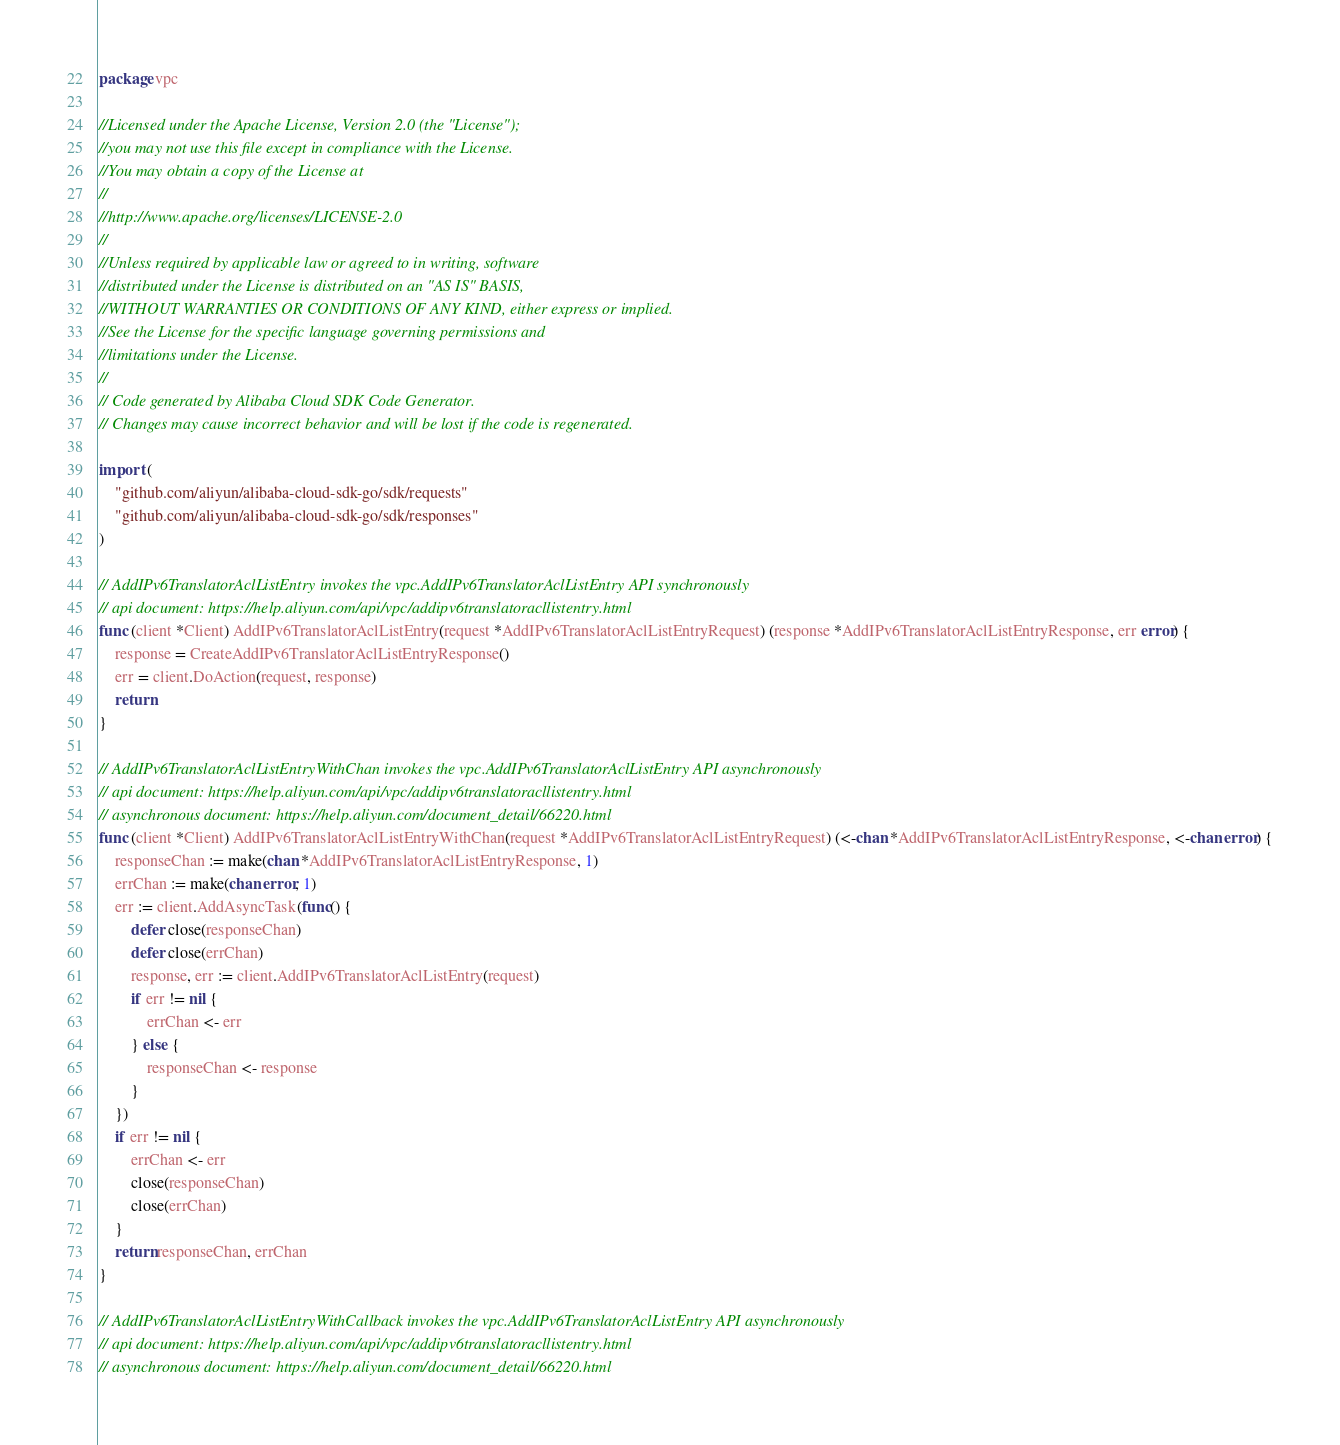Convert code to text. <code><loc_0><loc_0><loc_500><loc_500><_Go_>package vpc

//Licensed under the Apache License, Version 2.0 (the "License");
//you may not use this file except in compliance with the License.
//You may obtain a copy of the License at
//
//http://www.apache.org/licenses/LICENSE-2.0
//
//Unless required by applicable law or agreed to in writing, software
//distributed under the License is distributed on an "AS IS" BASIS,
//WITHOUT WARRANTIES OR CONDITIONS OF ANY KIND, either express or implied.
//See the License for the specific language governing permissions and
//limitations under the License.
//
// Code generated by Alibaba Cloud SDK Code Generator.
// Changes may cause incorrect behavior and will be lost if the code is regenerated.

import (
	"github.com/aliyun/alibaba-cloud-sdk-go/sdk/requests"
	"github.com/aliyun/alibaba-cloud-sdk-go/sdk/responses"
)

// AddIPv6TranslatorAclListEntry invokes the vpc.AddIPv6TranslatorAclListEntry API synchronously
// api document: https://help.aliyun.com/api/vpc/addipv6translatoracllistentry.html
func (client *Client) AddIPv6TranslatorAclListEntry(request *AddIPv6TranslatorAclListEntryRequest) (response *AddIPv6TranslatorAclListEntryResponse, err error) {
	response = CreateAddIPv6TranslatorAclListEntryResponse()
	err = client.DoAction(request, response)
	return
}

// AddIPv6TranslatorAclListEntryWithChan invokes the vpc.AddIPv6TranslatorAclListEntry API asynchronously
// api document: https://help.aliyun.com/api/vpc/addipv6translatoracllistentry.html
// asynchronous document: https://help.aliyun.com/document_detail/66220.html
func (client *Client) AddIPv6TranslatorAclListEntryWithChan(request *AddIPv6TranslatorAclListEntryRequest) (<-chan *AddIPv6TranslatorAclListEntryResponse, <-chan error) {
	responseChan := make(chan *AddIPv6TranslatorAclListEntryResponse, 1)
	errChan := make(chan error, 1)
	err := client.AddAsyncTask(func() {
		defer close(responseChan)
		defer close(errChan)
		response, err := client.AddIPv6TranslatorAclListEntry(request)
		if err != nil {
			errChan <- err
		} else {
			responseChan <- response
		}
	})
	if err != nil {
		errChan <- err
		close(responseChan)
		close(errChan)
	}
	return responseChan, errChan
}

// AddIPv6TranslatorAclListEntryWithCallback invokes the vpc.AddIPv6TranslatorAclListEntry API asynchronously
// api document: https://help.aliyun.com/api/vpc/addipv6translatoracllistentry.html
// asynchronous document: https://help.aliyun.com/document_detail/66220.html</code> 